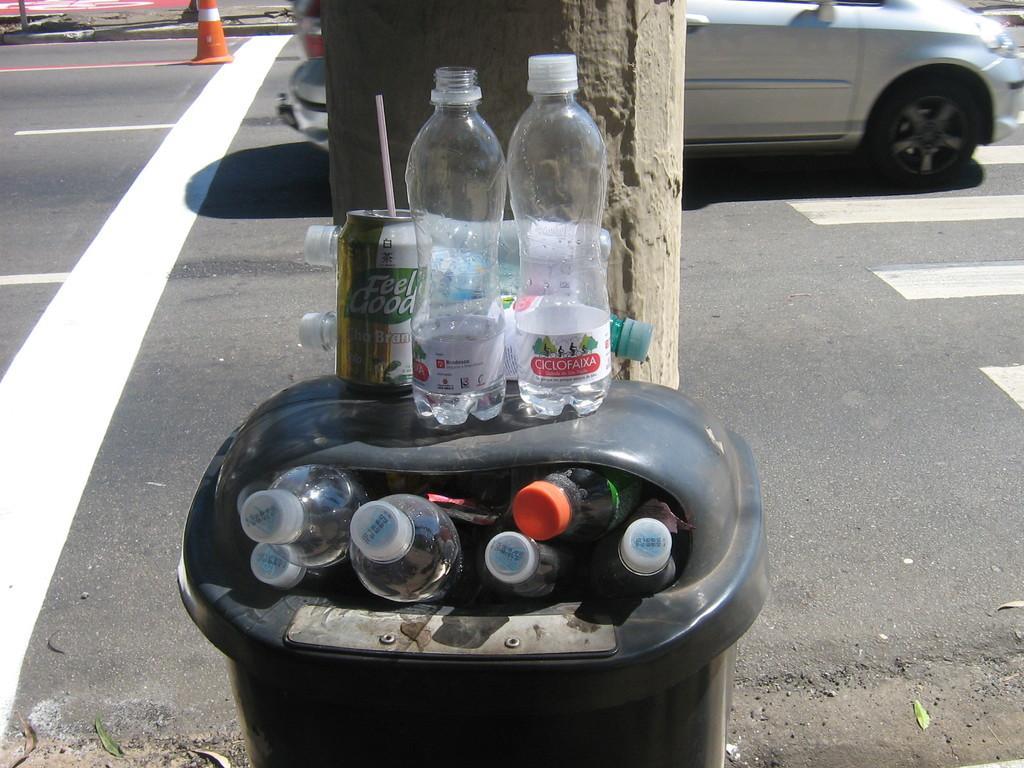Can you describe this image briefly? This bin is filled with bottles and above this bin there is a tin and bottles. Vehicles on road. This is cone. 